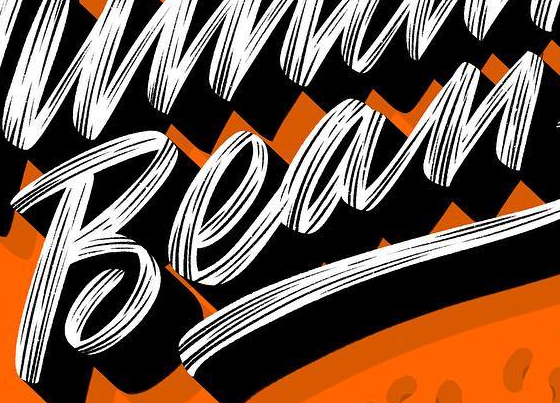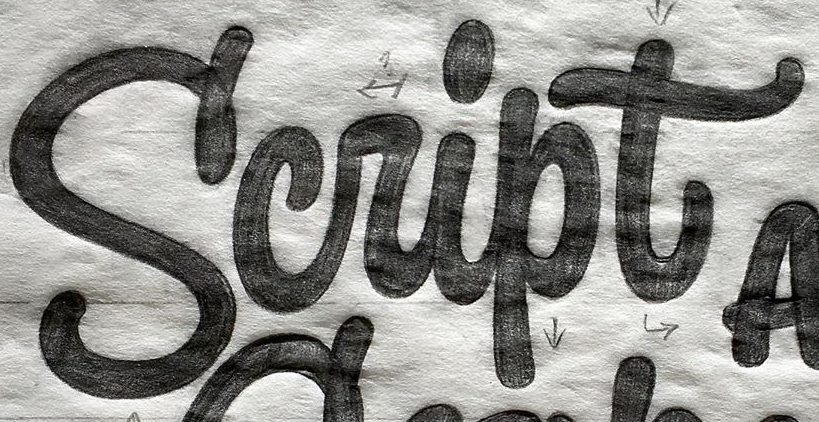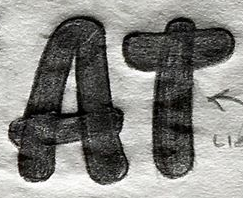What text is displayed in these images sequentially, separated by a semicolon? Bean; Script; AT 